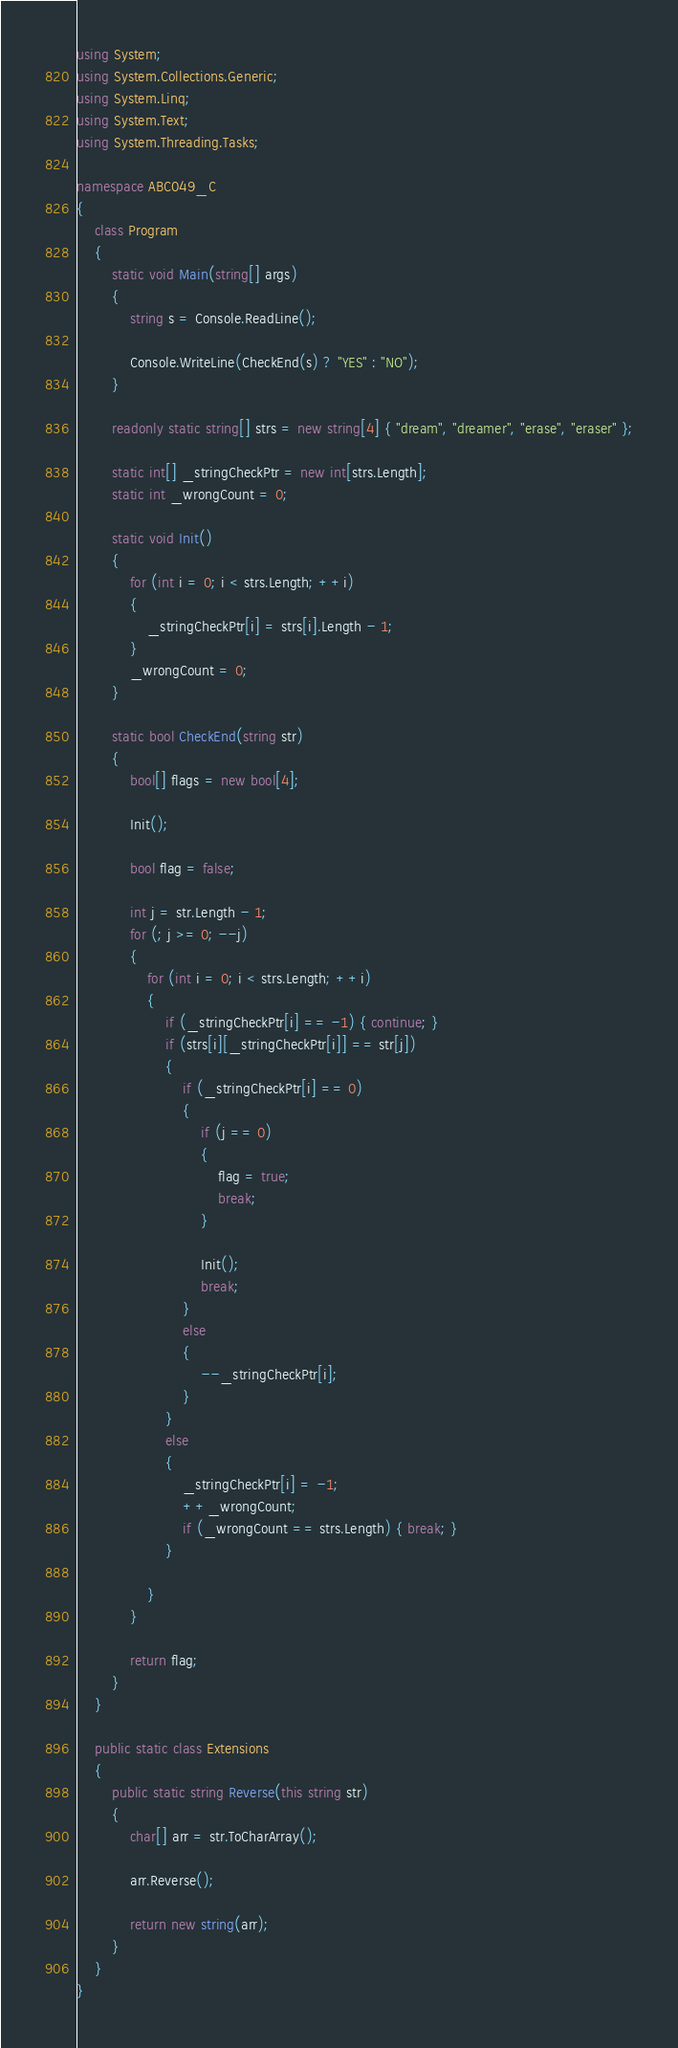Convert code to text. <code><loc_0><loc_0><loc_500><loc_500><_C#_>using System;
using System.Collections.Generic;
using System.Linq;
using System.Text;
using System.Threading.Tasks;

namespace ABC049_C
{
    class Program
    {
        static void Main(string[] args)
        {
            string s = Console.ReadLine();

            Console.WriteLine(CheckEnd(s) ? "YES" : "NO");
        }

        readonly static string[] strs = new string[4] { "dream", "dreamer", "erase", "eraser" };

        static int[] _stringCheckPtr = new int[strs.Length];
        static int _wrongCount = 0;

        static void Init()
        {
            for (int i = 0; i < strs.Length; ++i)
            {
                _stringCheckPtr[i] = strs[i].Length - 1;
            }
            _wrongCount = 0;
        }

        static bool CheckEnd(string str)
        {
            bool[] flags = new bool[4];

            Init();

            bool flag = false;

            int j = str.Length - 1;
            for (; j >= 0; --j)
            {
                for (int i = 0; i < strs.Length; ++i)
                {
                    if (_stringCheckPtr[i] == -1) { continue; }
                    if (strs[i][_stringCheckPtr[i]] == str[j])
                    {
                        if (_stringCheckPtr[i] == 0)
                        {
                            if (j == 0)
                            {
                                flag = true;
                                break;
                            }

                            Init();
                            break;
                        }
                        else
                        {
                            --_stringCheckPtr[i];
                        }
                    }
                    else
                    {
                        _stringCheckPtr[i] = -1;
                        ++_wrongCount;
                        if (_wrongCount == strs.Length) { break; }
                    }

                }
            }

            return flag;
        }
    }

    public static class Extensions
    {
        public static string Reverse(this string str)
        {
            char[] arr = str.ToCharArray();

            arr.Reverse();

            return new string(arr);
        }
    }
}
</code> 